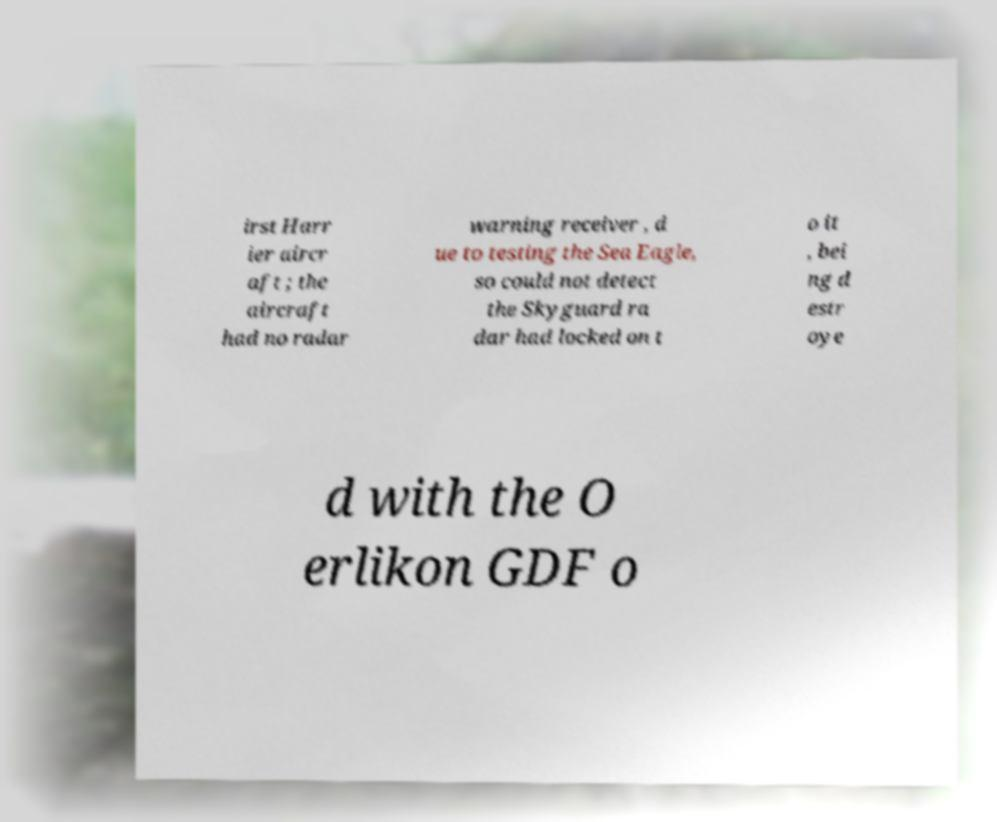I need the written content from this picture converted into text. Can you do that? irst Harr ier aircr aft ; the aircraft had no radar warning receiver , d ue to testing the Sea Eagle, so could not detect the Skyguard ra dar had locked on t o it , bei ng d estr oye d with the O erlikon GDF o 